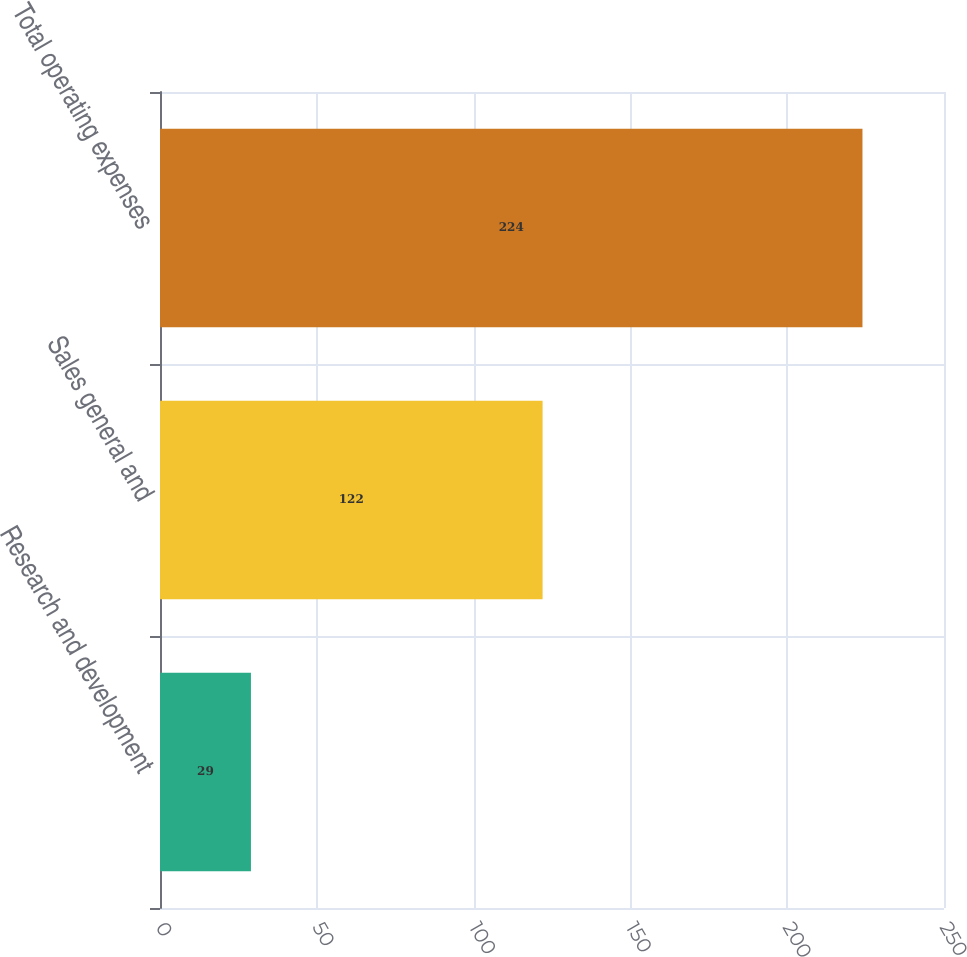Convert chart. <chart><loc_0><loc_0><loc_500><loc_500><bar_chart><fcel>Research and development<fcel>Sales general and<fcel>Total operating expenses<nl><fcel>29<fcel>122<fcel>224<nl></chart> 